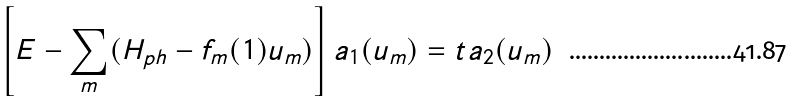<formula> <loc_0><loc_0><loc_500><loc_500>\left [ E - \sum _ { m } ( H _ { p h } - f _ { m } ( { 1 } ) u _ { m } ) \right ] a _ { 1 } ( u _ { m } ) = t a _ { 2 } ( u _ { m } )</formula> 